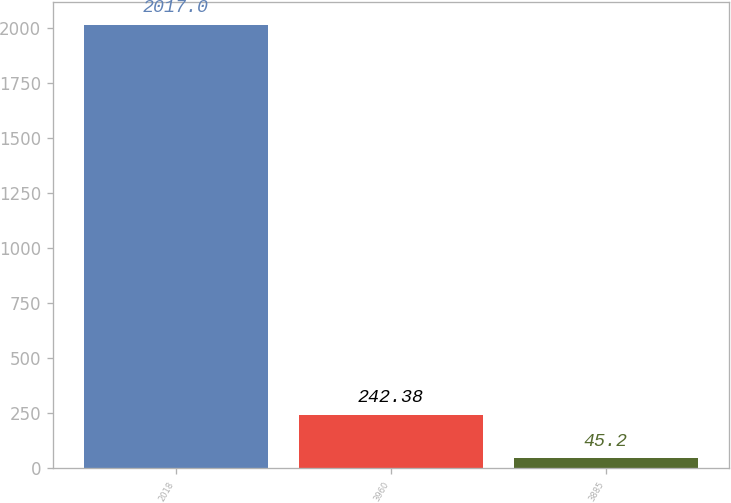Convert chart. <chart><loc_0><loc_0><loc_500><loc_500><bar_chart><fcel>2018<fcel>3960<fcel>3885<nl><fcel>2017<fcel>242.38<fcel>45.2<nl></chart> 